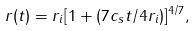Convert formula to latex. <formula><loc_0><loc_0><loc_500><loc_500>r ( t ) = r _ { i } [ 1 + ( 7 c _ { s } t / 4 r _ { i } ) ] ^ { 4 / 7 } ,</formula> 